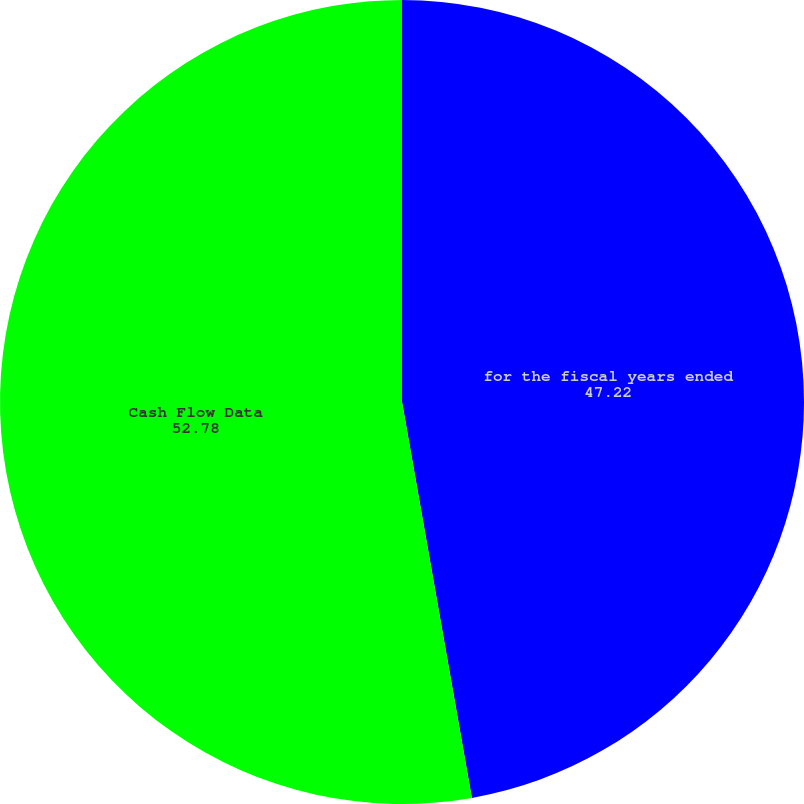Convert chart to OTSL. <chart><loc_0><loc_0><loc_500><loc_500><pie_chart><fcel>for the fiscal years ended<fcel>Cash Flow Data<nl><fcel>47.22%<fcel>52.78%<nl></chart> 